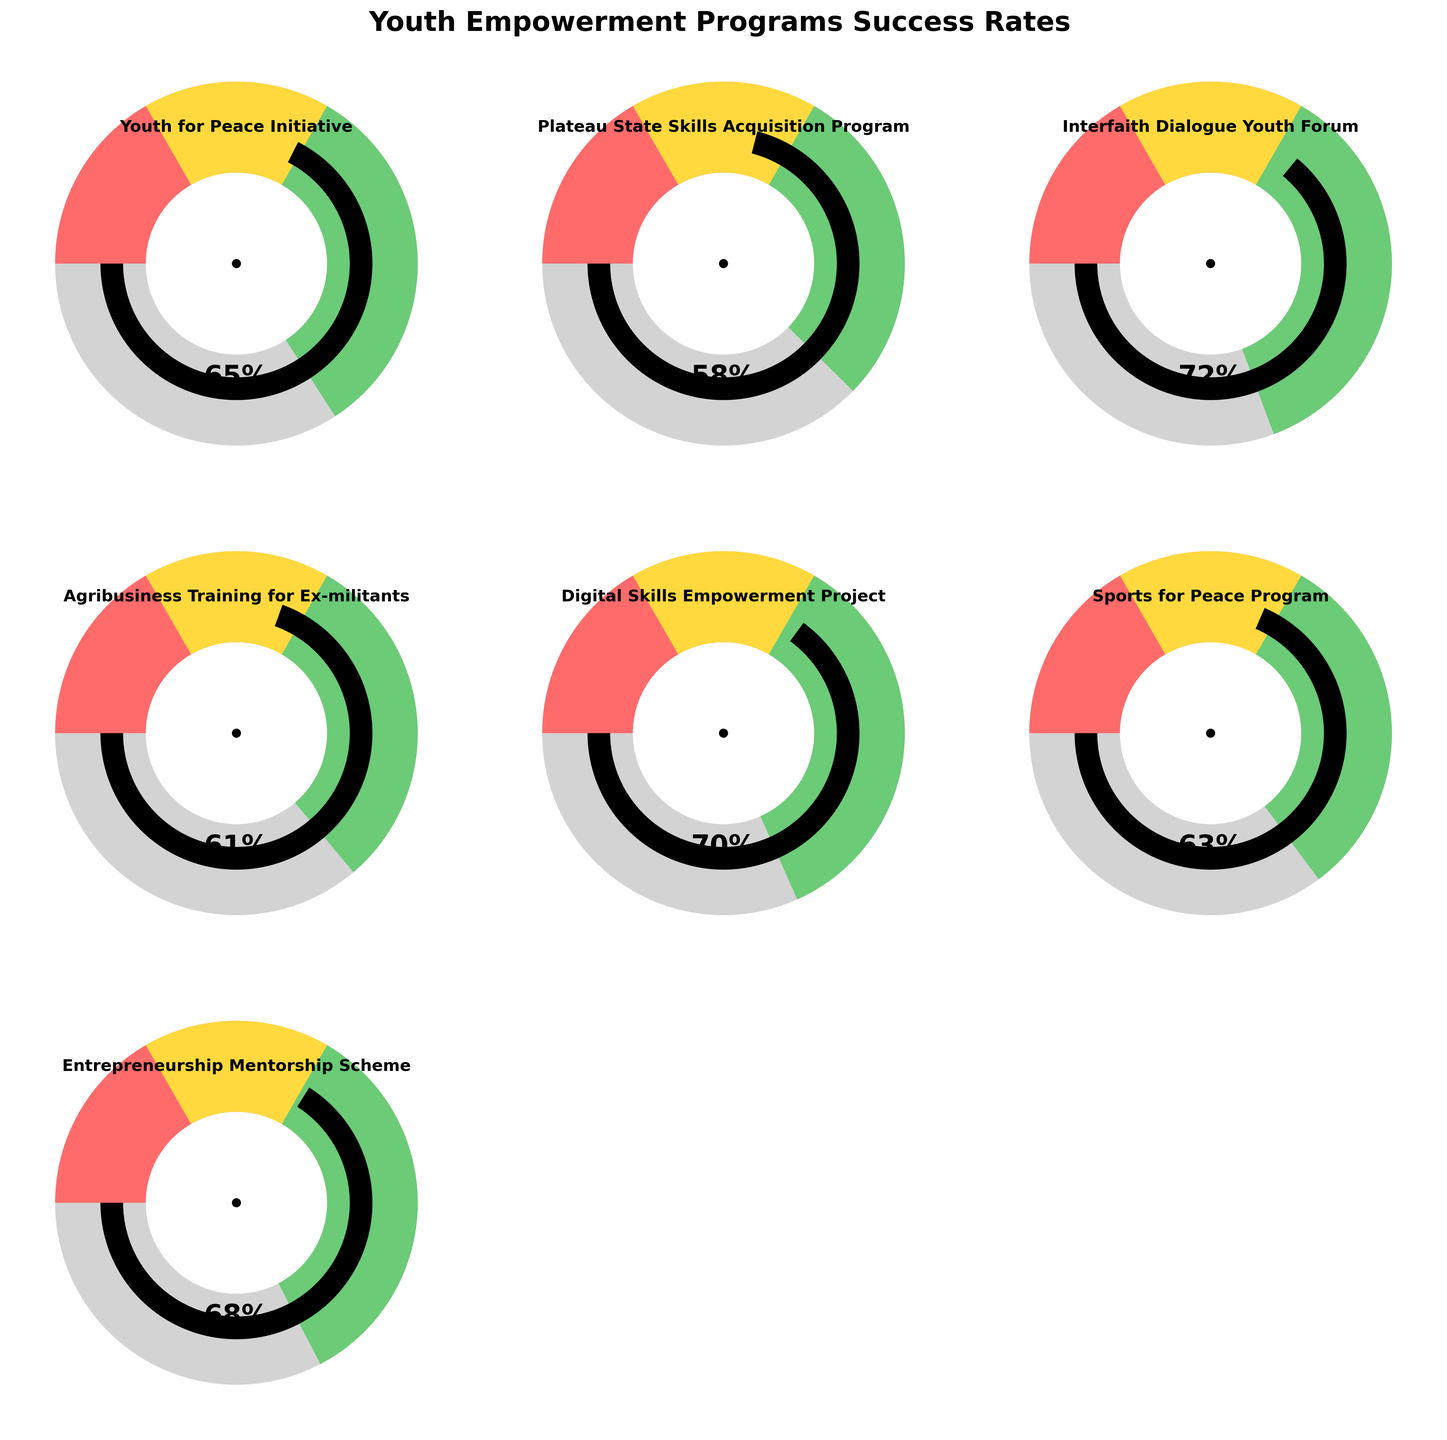What's the title of the figure? The title is displayed at the top of the figure and reads "Youth Empowerment Programs Success Rates" in bold font.
Answer: Youth Empowerment Programs Success Rates Which program has the highest success rate? The figure shows gauge charts for different programs, and "Interfaith Dialogue Youth Forum" has the highest value near 72%.
Answer: Interfaith Dialogue Youth Forum How many programs have a success rate above 60%? By checking each gauge chart, the programs with success rates above 60% are "Youth for Peace Initiative," "Interfaith Dialogue Youth Forum," "Digital Skills Empowerment Project," "Sports for Peace Program," and "Entrepreneurship Mentorship Scheme." This gives us a total of 5 programs.
Answer: 5 What's the average success rate across all programs? To get the average, sum all the success rates (65 + 58 + 72 + 61 + 70 + 63 + 68) and divide by the number of programs (7). This results in an average of (457 / 7) = 65.29.
Answer: 65.29 What colors are used to represent the different success rate ranges? The gauge charts use three colors to display success rate ranges. From left to right (low to high success rate), these colors are red, yellow, and green.
Answer: Red, Yellow, Green Which program has the lowest success rate? By observing the gauge charts, "Plateau State Skills Acquisition Program" has the lowest value set at 58%.
Answer: Plateau State Skills Acquisition Program What's the success rate of the "Sports for Peace Program"? The gauge chart for "Sports for Peace Program" indicates a value close to 63%.
Answer: 63 What's the difference between the highest and the lowest success rates? The highest success rate is 72% ("Interfaith Dialogue Youth Forum") and the lowest rate is 58% ("Plateau State Skills Acquisition Program"). The difference is 72 - 58 = 14%.
Answer: 14 Which programs fall in the yellow range? The yellow range typically represents moderate success rates. "Agribusiness Training for Ex-militants," "Sports for Peace Program," and "Plateau State Skills Acquisition Program" are shown in the yellow range.
Answer: Agribusiness Training for Ex-militants, Sports for Peace Program, Plateau State Skills Acquisition Program Which programs appear more successful based on the shown success rates? Programs in the green range, which indicates higher success rates, include "Interfaith Dialogue Youth Forum," "Youth for Peace Initiative," "Digital Skills Empowerment Project," and "Entrepreneurship Mentorship Scheme."
Answer: Interfaith Dialogue Youth Forum, Youth for Peace Initiative, Digital Skills Empowerment Project, Entrepreneurship Mentorship Scheme 